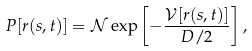Convert formula to latex. <formula><loc_0><loc_0><loc_500><loc_500>P [ r ( s , t ) ] = \mathcal { N } \exp \left [ - \frac { \mathcal { V } [ r ( s , t ) ] } { D / 2 } \right ] ,</formula> 